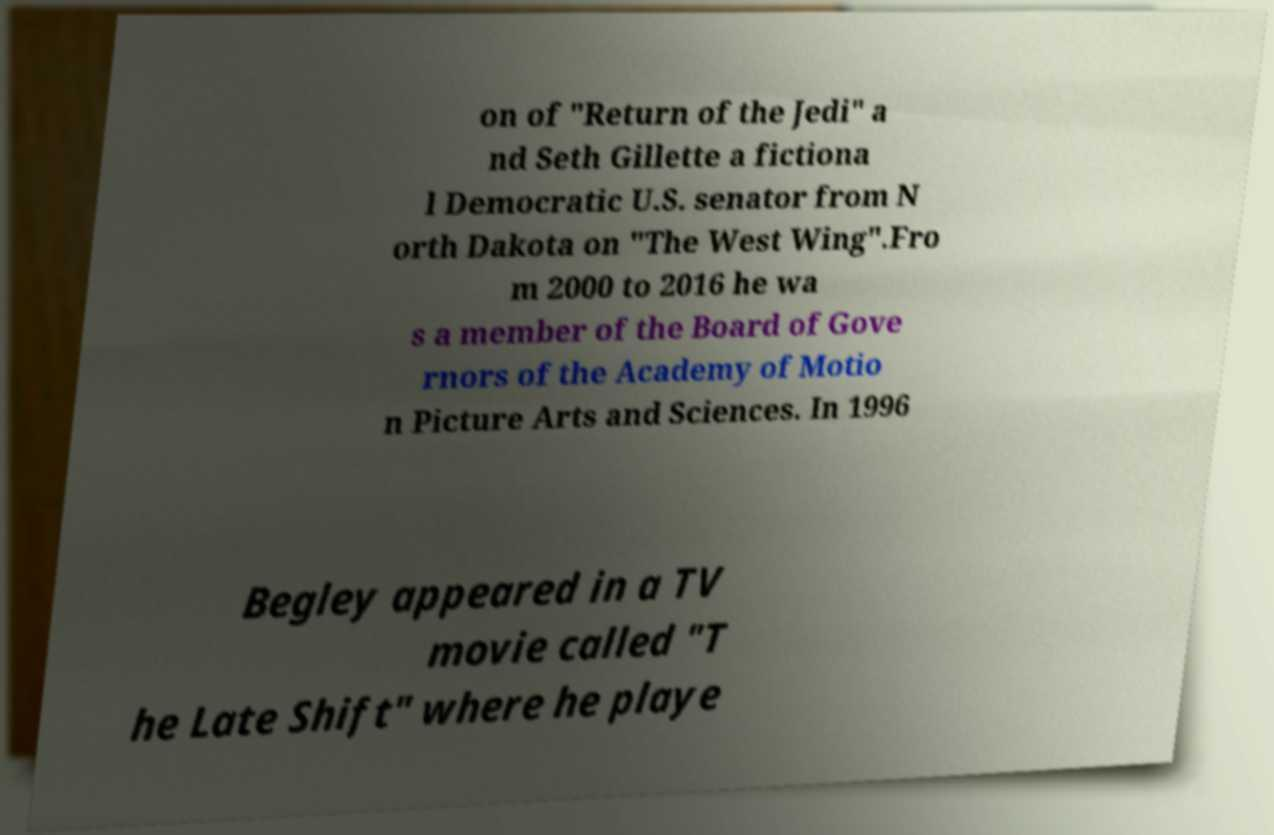Could you assist in decoding the text presented in this image and type it out clearly? on of "Return of the Jedi" a nd Seth Gillette a fictiona l Democratic U.S. senator from N orth Dakota on "The West Wing".Fro m 2000 to 2016 he wa s a member of the Board of Gove rnors of the Academy of Motio n Picture Arts and Sciences. In 1996 Begley appeared in a TV movie called "T he Late Shift" where he playe 